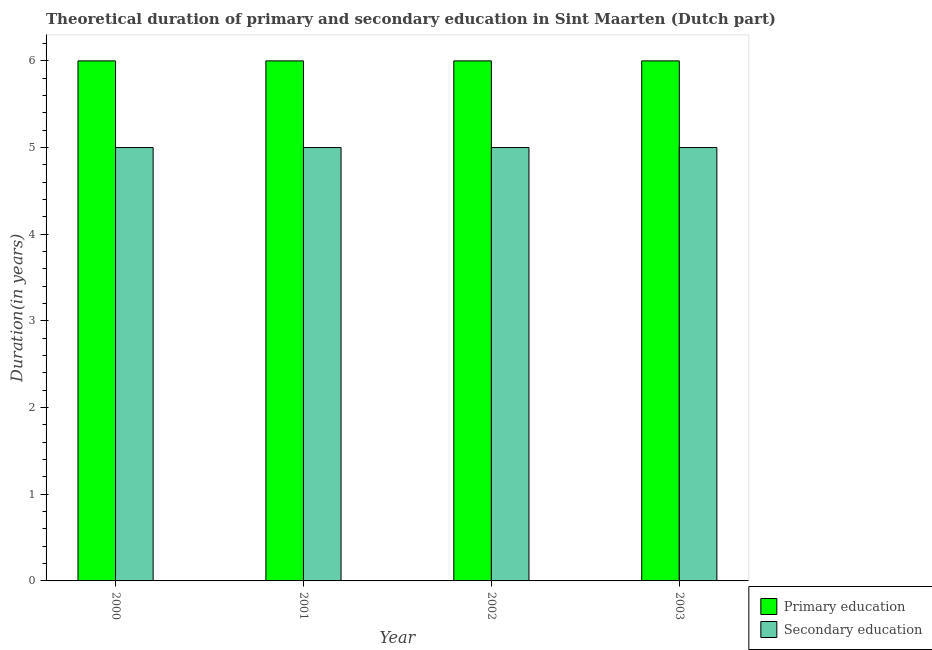How many different coloured bars are there?
Your answer should be very brief. 2. How many groups of bars are there?
Your answer should be compact. 4. How many bars are there on the 4th tick from the left?
Offer a terse response. 2. In how many cases, is the number of bars for a given year not equal to the number of legend labels?
Ensure brevity in your answer.  0. What is the duration of primary education in 2001?
Keep it short and to the point. 6. Across all years, what is the maximum duration of primary education?
Keep it short and to the point. 6. In which year was the duration of primary education maximum?
Ensure brevity in your answer.  2000. In which year was the duration of primary education minimum?
Offer a very short reply. 2000. What is the total duration of primary education in the graph?
Ensure brevity in your answer.  24. What is the difference between the duration of primary education in 2001 and that in 2002?
Provide a succinct answer. 0. What is the difference between the duration of primary education in 2001 and the duration of secondary education in 2000?
Make the answer very short. 0. In the year 2001, what is the difference between the duration of secondary education and duration of primary education?
Your response must be concise. 0. In how many years, is the duration of secondary education greater than 4.4 years?
Offer a very short reply. 4. What is the ratio of the duration of secondary education in 2002 to that in 2003?
Offer a very short reply. 1. What is the difference between the highest and the second highest duration of primary education?
Give a very brief answer. 0. Is the sum of the duration of primary education in 2001 and 2002 greater than the maximum duration of secondary education across all years?
Provide a short and direct response. Yes. What does the 1st bar from the right in 2002 represents?
Your answer should be very brief. Secondary education. How many bars are there?
Your response must be concise. 8. Are all the bars in the graph horizontal?
Keep it short and to the point. No. What is the difference between two consecutive major ticks on the Y-axis?
Offer a terse response. 1. Does the graph contain grids?
Make the answer very short. No. What is the title of the graph?
Your response must be concise. Theoretical duration of primary and secondary education in Sint Maarten (Dutch part). What is the label or title of the X-axis?
Your response must be concise. Year. What is the label or title of the Y-axis?
Provide a short and direct response. Duration(in years). What is the Duration(in years) in Primary education in 2002?
Provide a succinct answer. 6. What is the Duration(in years) in Secondary education in 2002?
Your answer should be very brief. 5. What is the Duration(in years) of Secondary education in 2003?
Your answer should be compact. 5. Across all years, what is the maximum Duration(in years) in Primary education?
Your answer should be very brief. 6. Across all years, what is the minimum Duration(in years) in Primary education?
Offer a very short reply. 6. What is the total Duration(in years) of Secondary education in the graph?
Your answer should be very brief. 20. What is the difference between the Duration(in years) in Primary education in 2000 and that in 2001?
Your response must be concise. 0. What is the difference between the Duration(in years) in Secondary education in 2000 and that in 2001?
Make the answer very short. 0. What is the difference between the Duration(in years) in Secondary education in 2000 and that in 2002?
Your answer should be very brief. 0. What is the difference between the Duration(in years) in Primary education in 2000 and that in 2003?
Provide a short and direct response. 0. What is the difference between the Duration(in years) of Secondary education in 2000 and that in 2003?
Make the answer very short. 0. What is the difference between the Duration(in years) of Primary education in 2001 and that in 2002?
Give a very brief answer. 0. What is the difference between the Duration(in years) of Secondary education in 2001 and that in 2002?
Make the answer very short. 0. What is the difference between the Duration(in years) in Primary education in 2001 and that in 2003?
Offer a terse response. 0. What is the difference between the Duration(in years) of Primary education in 2002 and that in 2003?
Your answer should be compact. 0. What is the difference between the Duration(in years) in Primary education in 2000 and the Duration(in years) in Secondary education in 2002?
Provide a succinct answer. 1. What is the difference between the Duration(in years) of Primary education in 2000 and the Duration(in years) of Secondary education in 2003?
Ensure brevity in your answer.  1. What is the difference between the Duration(in years) of Primary education in 2001 and the Duration(in years) of Secondary education in 2002?
Your response must be concise. 1. What is the difference between the Duration(in years) of Primary education in 2001 and the Duration(in years) of Secondary education in 2003?
Make the answer very short. 1. What is the difference between the Duration(in years) of Primary education in 2002 and the Duration(in years) of Secondary education in 2003?
Provide a short and direct response. 1. What is the average Duration(in years) in Primary education per year?
Ensure brevity in your answer.  6. What is the average Duration(in years) in Secondary education per year?
Offer a terse response. 5. What is the ratio of the Duration(in years) of Primary education in 2000 to that in 2001?
Your answer should be compact. 1. What is the ratio of the Duration(in years) of Secondary education in 2000 to that in 2001?
Give a very brief answer. 1. What is the ratio of the Duration(in years) in Secondary education in 2000 to that in 2002?
Your answer should be compact. 1. What is the ratio of the Duration(in years) in Secondary education in 2001 to that in 2002?
Make the answer very short. 1. What is the ratio of the Duration(in years) in Primary education in 2001 to that in 2003?
Offer a terse response. 1. What is the difference between the highest and the second highest Duration(in years) in Secondary education?
Make the answer very short. 0. What is the difference between the highest and the lowest Duration(in years) of Primary education?
Your answer should be very brief. 0. What is the difference between the highest and the lowest Duration(in years) in Secondary education?
Your answer should be compact. 0. 